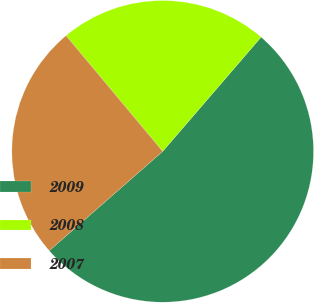Convert chart to OTSL. <chart><loc_0><loc_0><loc_500><loc_500><pie_chart><fcel>2009<fcel>2008<fcel>2007<nl><fcel>52.24%<fcel>22.39%<fcel>25.37%<nl></chart> 